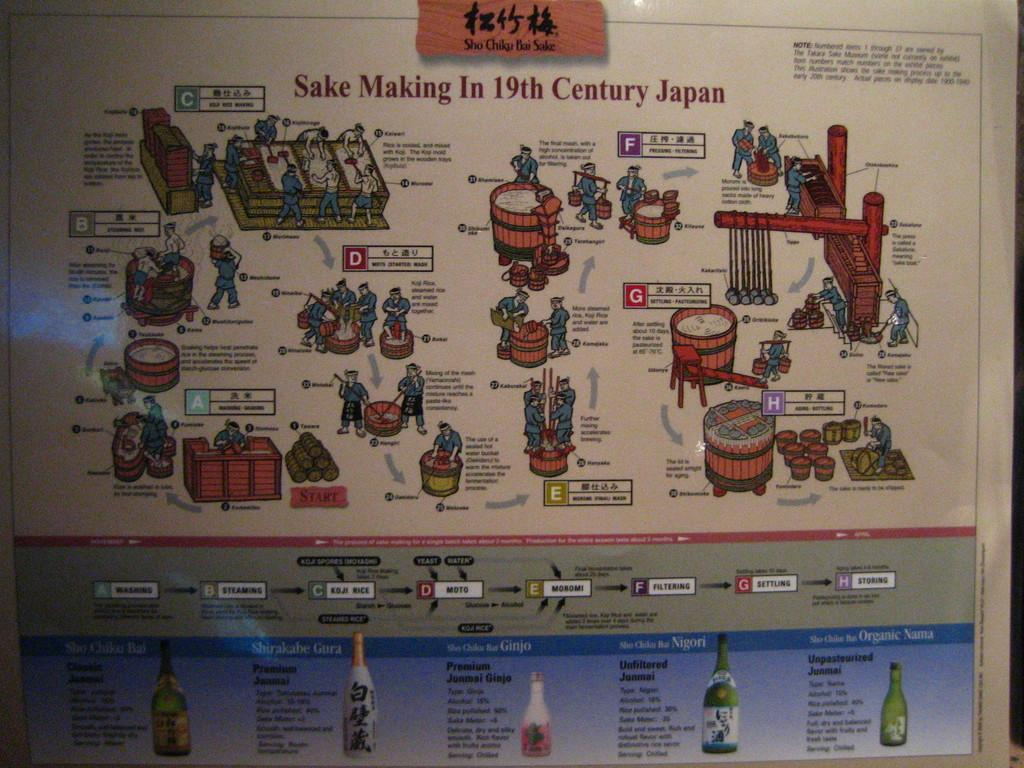<image>
Offer a succinct explanation of the picture presented. A poster that diagrams the Making of Sake in the 19th century in Japan. 